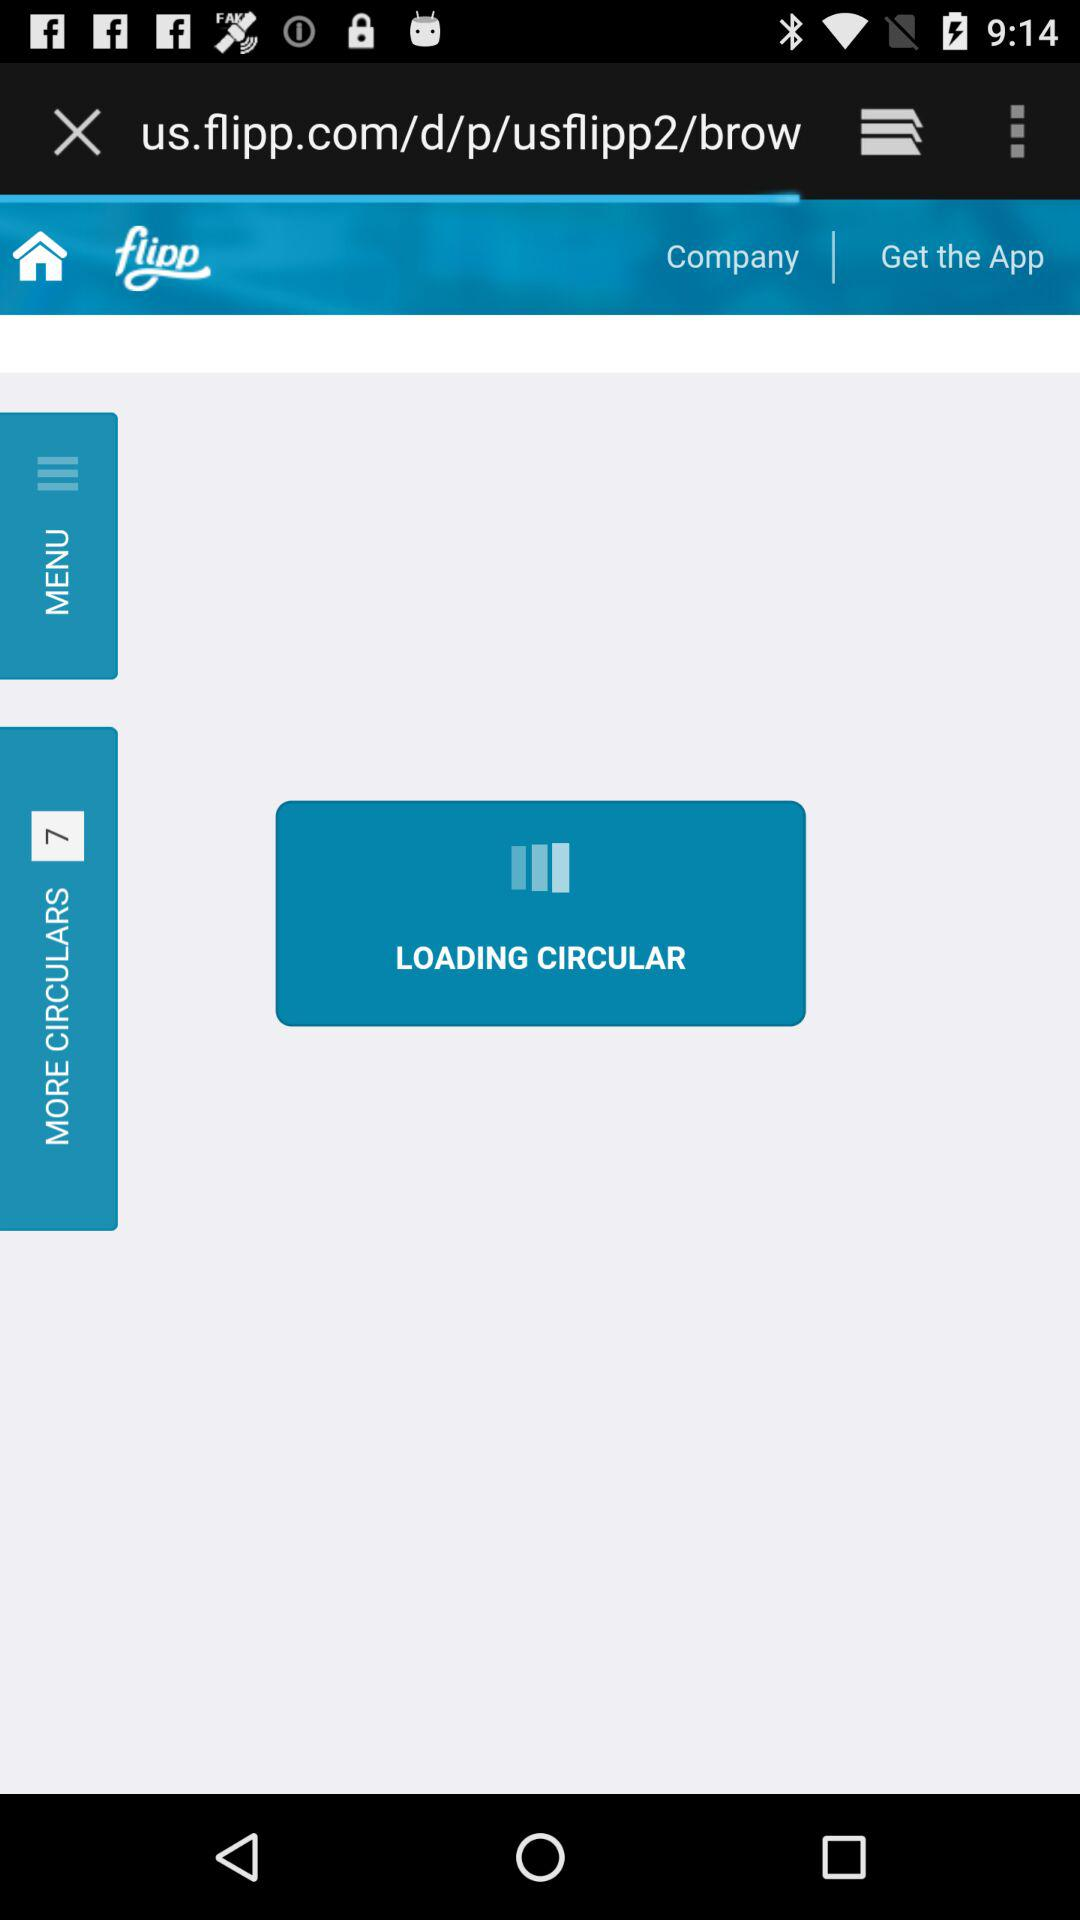How many "More Circulars" are there? There are 7 "More Circulars". 